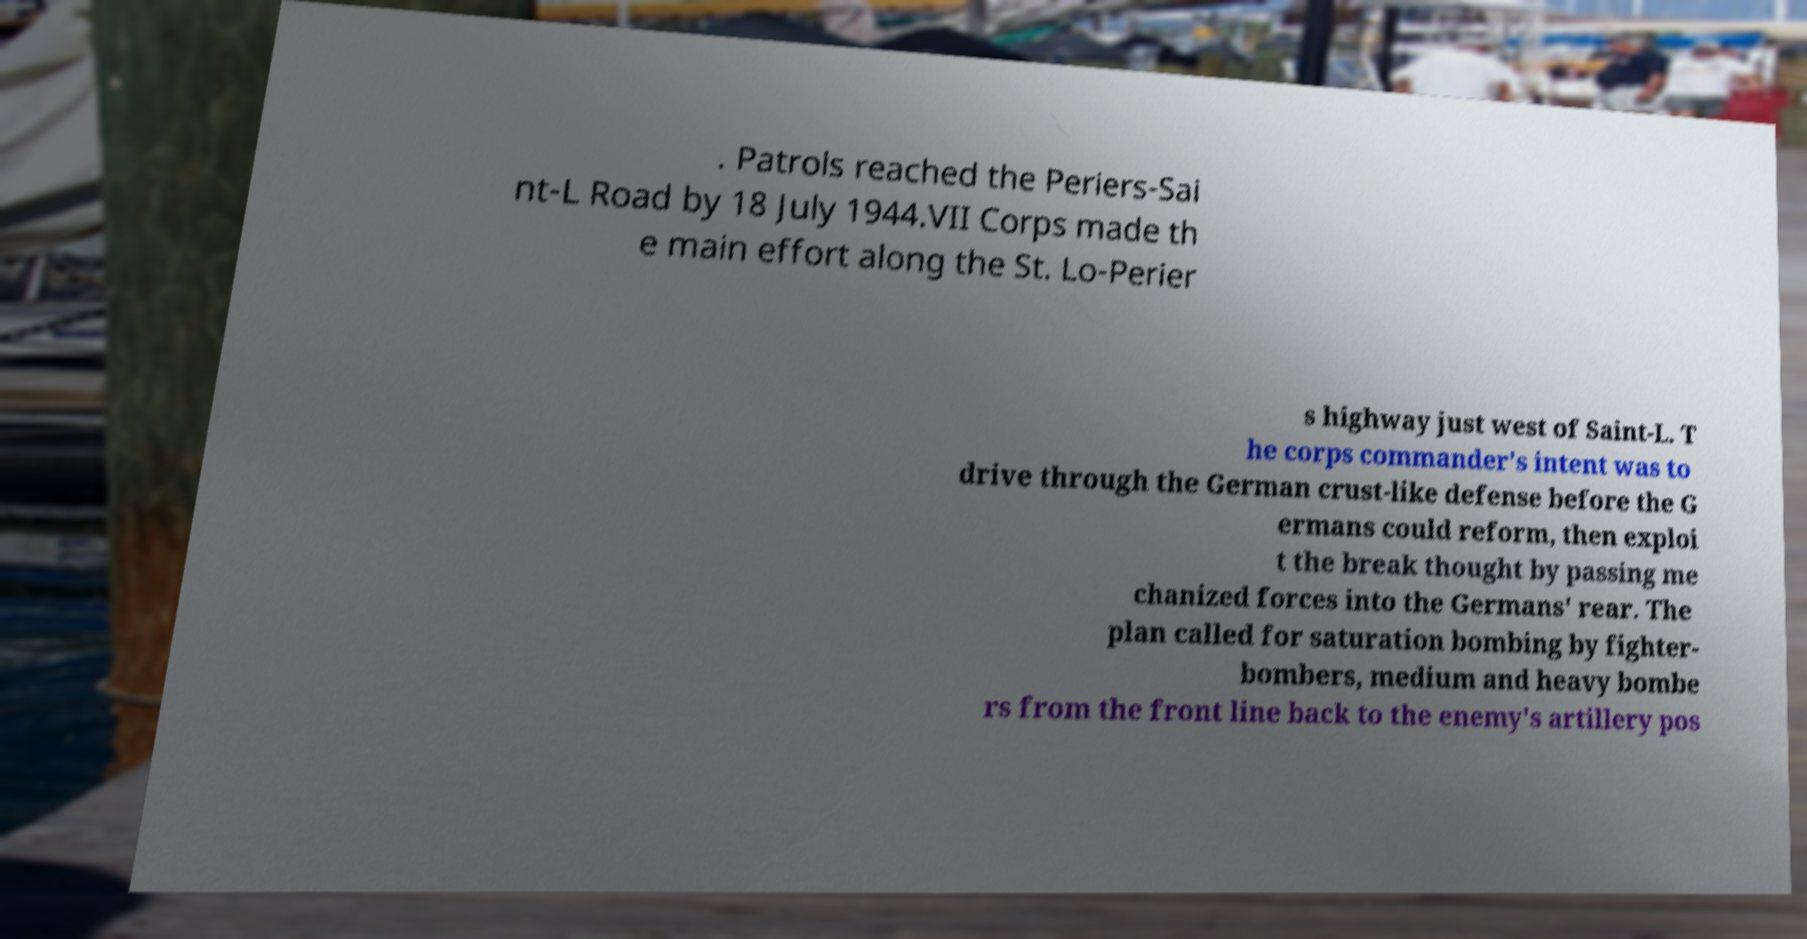Could you assist in decoding the text presented in this image and type it out clearly? . Patrols reached the Periers-Sai nt-L Road by 18 July 1944.VII Corps made th e main effort along the St. Lo-Perier s highway just west of Saint-L. T he corps commander's intent was to drive through the German crust-like defense before the G ermans could reform, then exploi t the break thought by passing me chanized forces into the Germans' rear. The plan called for saturation bombing by fighter- bombers, medium and heavy bombe rs from the front line back to the enemy's artillery pos 